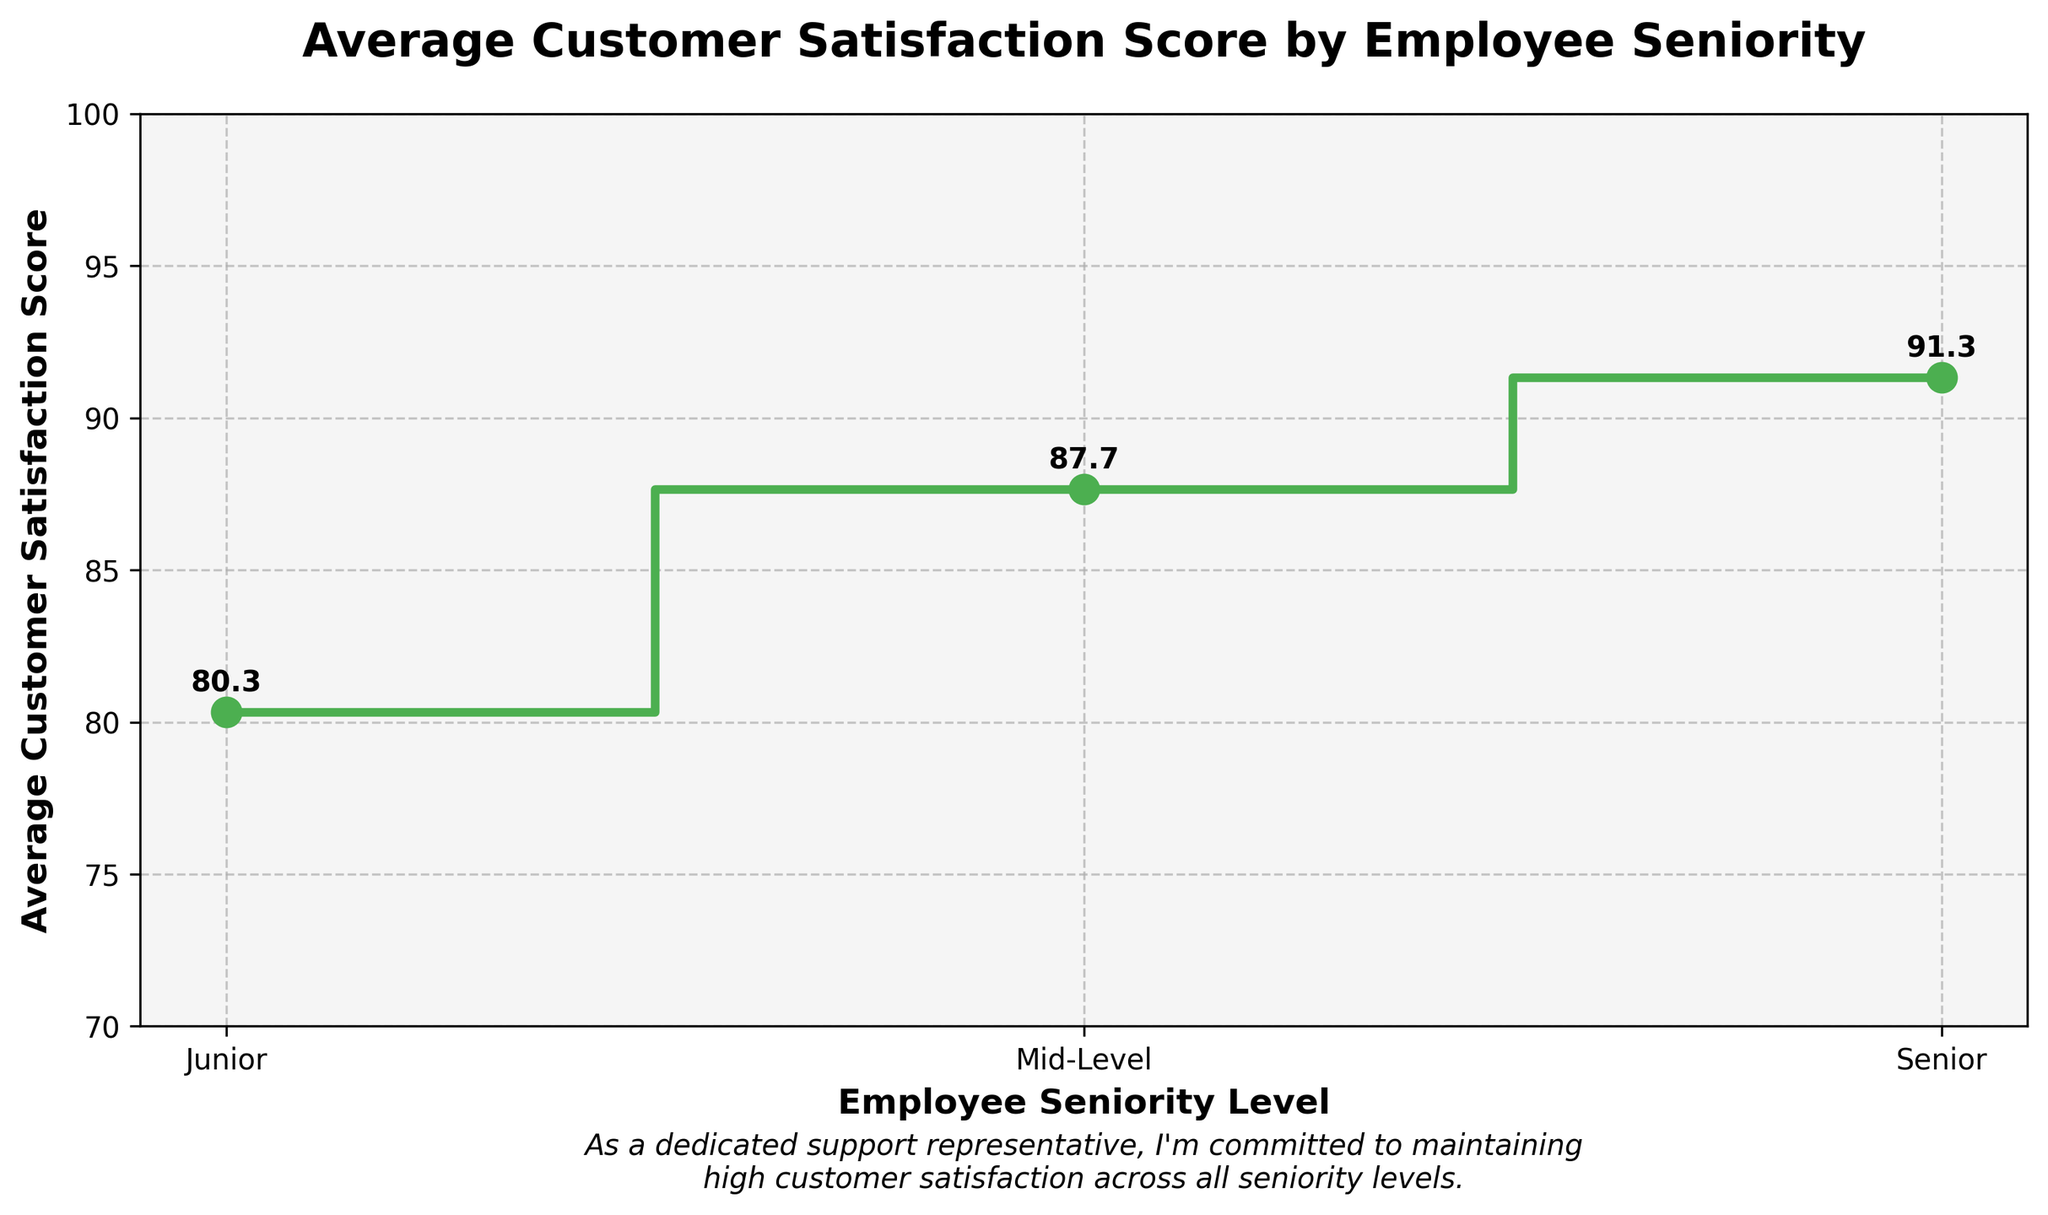What is the title of the plot? The title of the plot is clearly written at the top of the figure in a larger, bold font.
Answer: Average Customer Satisfaction Score by Employee Seniority What are the average customer satisfaction scores for mid-level employees? Mid-level scores are labeled and annotated on the plot at the mid-point for the mid-level seniority.
Answer: 87.67 What is the overall trend in customer satisfaction scores as employee seniority increases? By observing the stair plot, customer satisfaction scores generally trend upward as seniority increases from Junior to Senior.
Answer: Upward Which seniority level has the highest average customer satisfaction score? The highest annotated score on the plot is associated with the Senior level.
Answer: Senior Compare the average customer satisfaction scores between Junior and Senior employees. The average scores for Junior and Senior employees are annotated on the plot. Subtract the Junior score from the Senior score: 91.33 - 80.33.
Answer: 11 What is the difference in average customer satisfaction scores between Mid-Level and Senior employees? Identify the average scores for Mid-Level and Senior, and then subtract the Mid-Level score from the Senior score: 91.33 - 87.67.
Answer: 3.66 Which customer satisfaction score range can be found on the y-axis? The y-axis spans from 70 to 100 based on the y-axis range specified in the plot.
Answer: 70-100 What was added to the plot to make it more appealing and readable? Several elements are added: gridlines, background color, value labels, and a personalized note at the bottom.
Answer: Grid, background color, value labels, personalized note Identify the color used for the line and markers in the plot. The line and markers are colored uniformly with a vibrant, eye-catching green.
Answer: Green How does the plot visually differentiate between the different seniority levels? The three seniority levels are plotted in a stair-step formation, with distinct markers at each level, and the levels are clearly labeled.
Answer: Stair-step formation with markers 